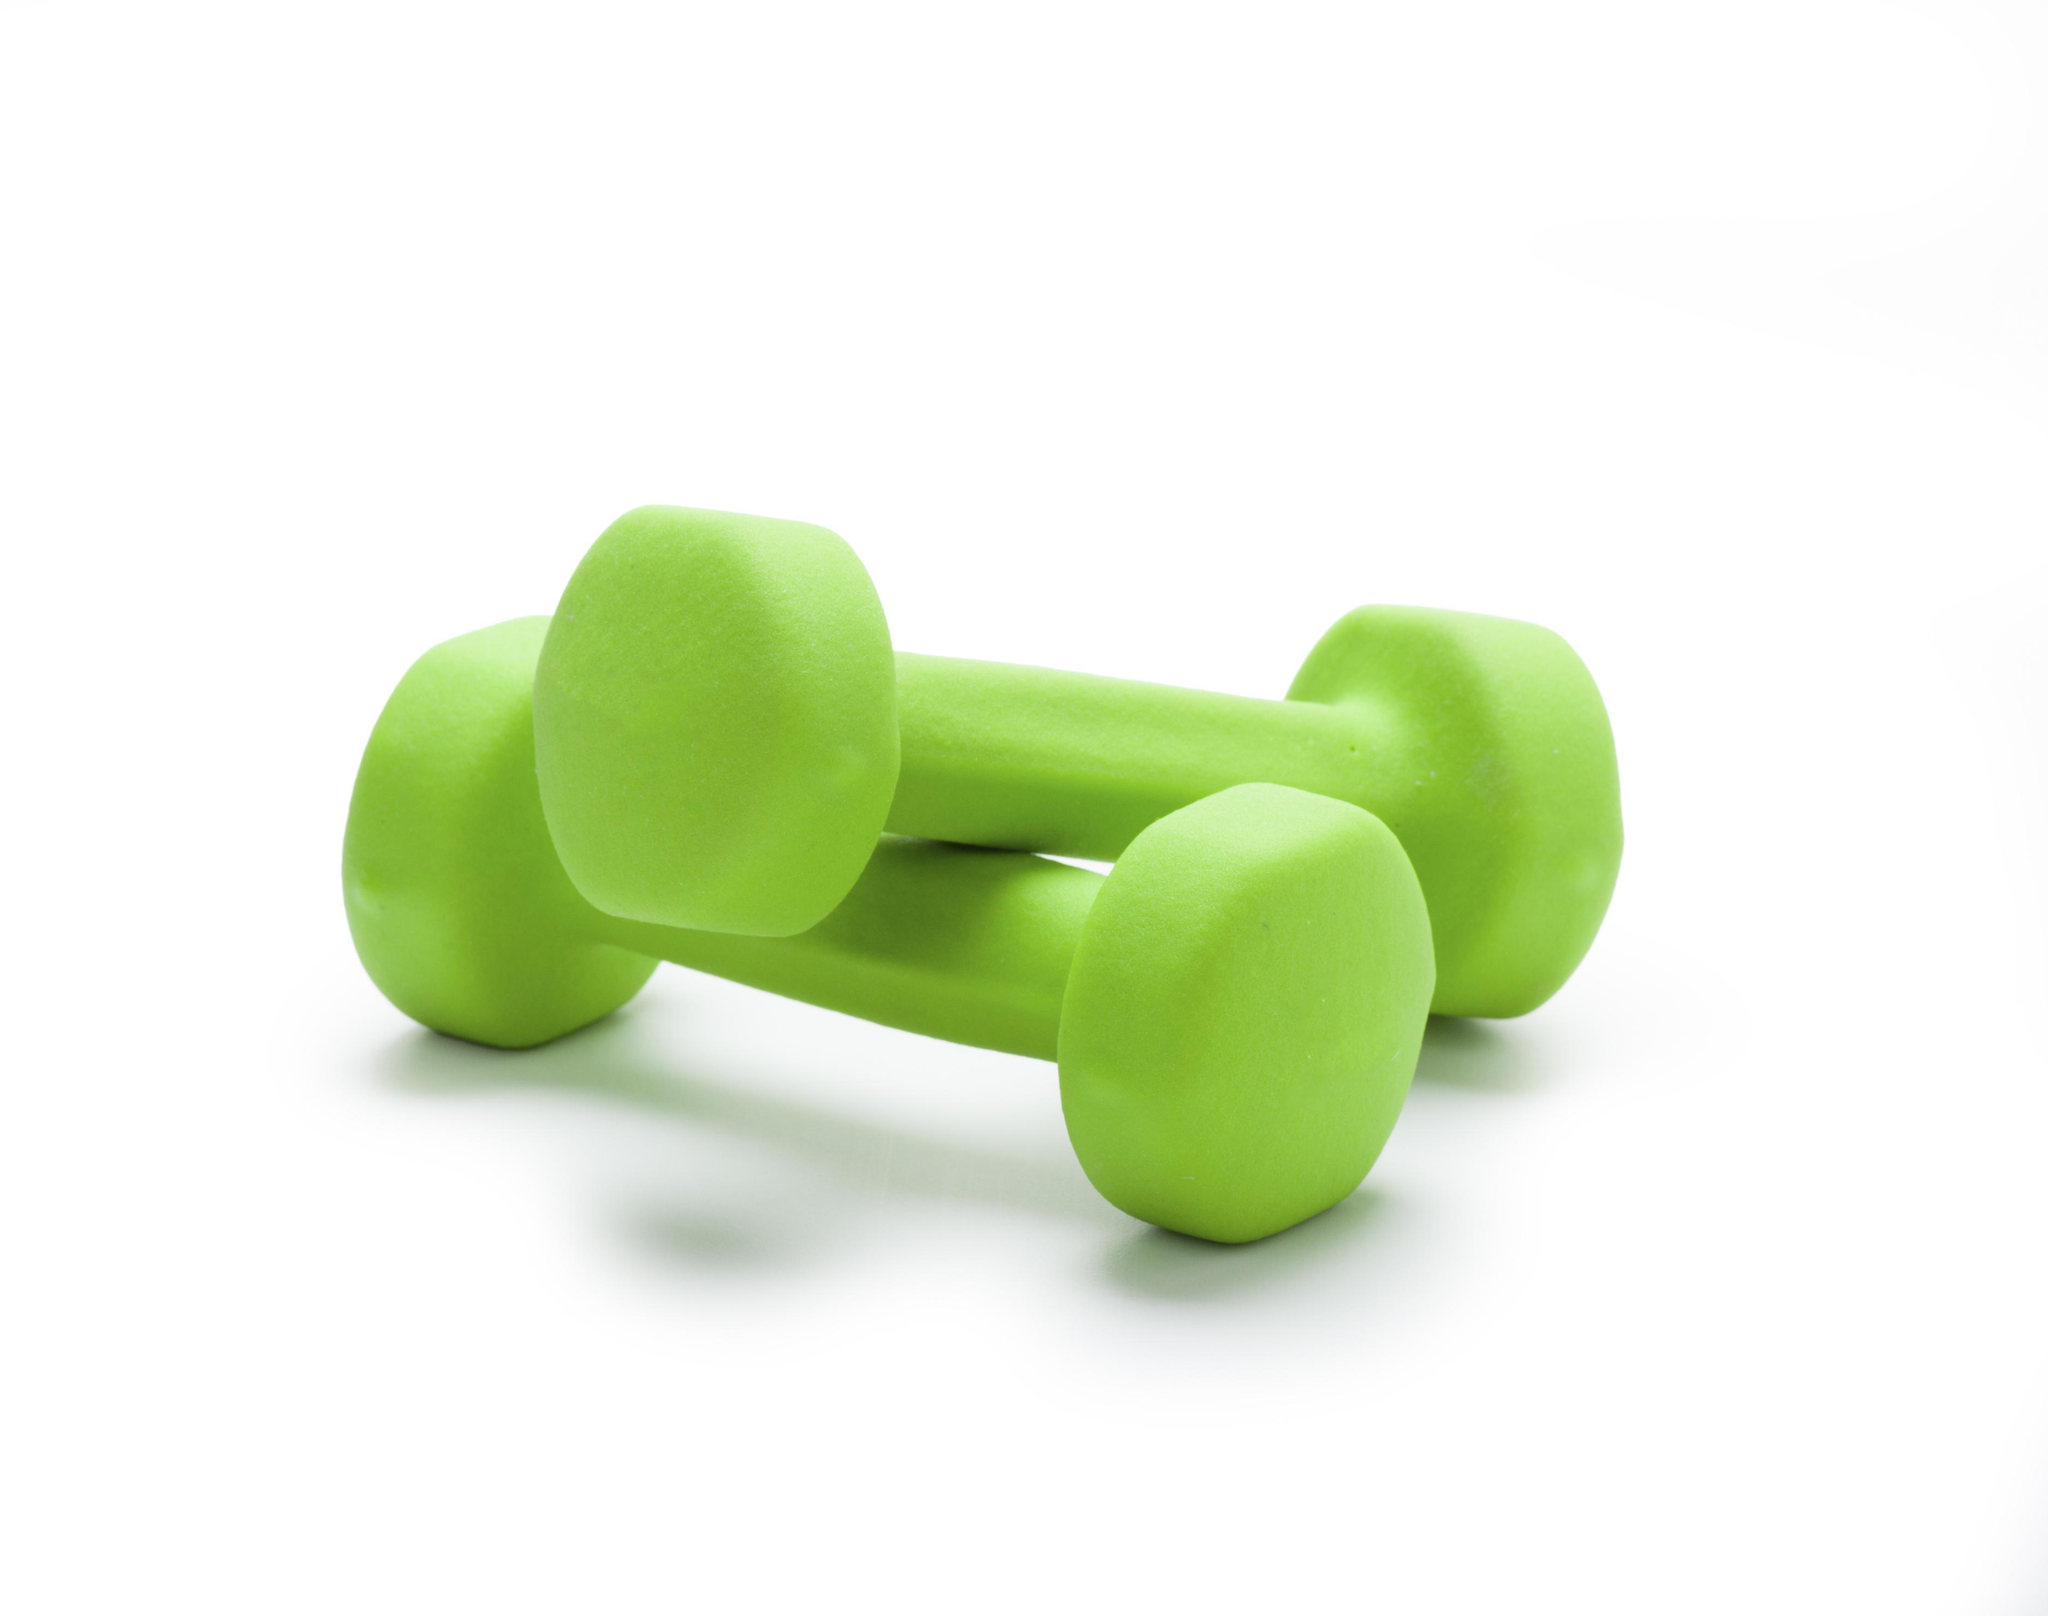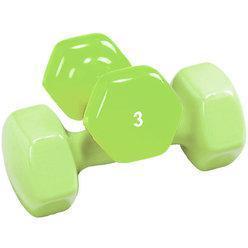The first image is the image on the left, the second image is the image on the right. For the images shown, is this caption "All of the weights are green in both images." true? Answer yes or no. Yes. The first image is the image on the left, the second image is the image on the right. Analyze the images presented: Is the assertion "Images contain green dumbbells and contain the same number of dumbbells." valid? Answer yes or no. Yes. 